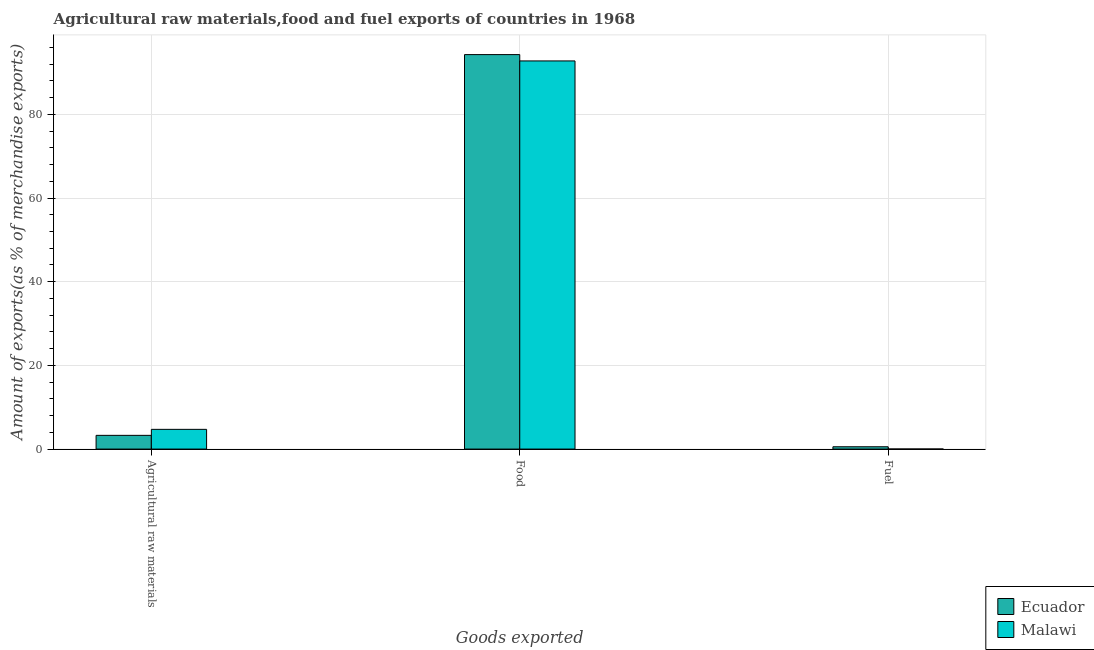How many different coloured bars are there?
Provide a succinct answer. 2. Are the number of bars on each tick of the X-axis equal?
Keep it short and to the point. Yes. How many bars are there on the 1st tick from the left?
Ensure brevity in your answer.  2. How many bars are there on the 2nd tick from the right?
Offer a terse response. 2. What is the label of the 3rd group of bars from the left?
Provide a short and direct response. Fuel. What is the percentage of fuel exports in Ecuador?
Keep it short and to the point. 0.55. Across all countries, what is the maximum percentage of food exports?
Offer a terse response. 94.29. Across all countries, what is the minimum percentage of food exports?
Offer a very short reply. 92.77. In which country was the percentage of food exports maximum?
Your response must be concise. Ecuador. In which country was the percentage of fuel exports minimum?
Provide a short and direct response. Malawi. What is the total percentage of fuel exports in the graph?
Provide a short and direct response. 0.56. What is the difference between the percentage of food exports in Ecuador and that in Malawi?
Give a very brief answer. 1.51. What is the difference between the percentage of fuel exports in Ecuador and the percentage of food exports in Malawi?
Provide a short and direct response. -92.22. What is the average percentage of fuel exports per country?
Offer a terse response. 0.28. What is the difference between the percentage of raw materials exports and percentage of fuel exports in Ecuador?
Give a very brief answer. 2.73. In how many countries, is the percentage of fuel exports greater than 12 %?
Provide a succinct answer. 0. What is the ratio of the percentage of fuel exports in Malawi to that in Ecuador?
Your answer should be compact. 0.02. Is the difference between the percentage of fuel exports in Malawi and Ecuador greater than the difference between the percentage of raw materials exports in Malawi and Ecuador?
Offer a very short reply. No. What is the difference between the highest and the second highest percentage of food exports?
Ensure brevity in your answer.  1.51. What is the difference between the highest and the lowest percentage of raw materials exports?
Your answer should be very brief. 1.43. In how many countries, is the percentage of food exports greater than the average percentage of food exports taken over all countries?
Offer a terse response. 1. Is the sum of the percentage of raw materials exports in Ecuador and Malawi greater than the maximum percentage of fuel exports across all countries?
Offer a very short reply. Yes. What does the 1st bar from the left in Fuel represents?
Your answer should be very brief. Ecuador. What does the 2nd bar from the right in Agricultural raw materials represents?
Give a very brief answer. Ecuador. Is it the case that in every country, the sum of the percentage of raw materials exports and percentage of food exports is greater than the percentage of fuel exports?
Give a very brief answer. Yes. Are all the bars in the graph horizontal?
Keep it short and to the point. No. How many countries are there in the graph?
Your response must be concise. 2. What is the difference between two consecutive major ticks on the Y-axis?
Your response must be concise. 20. Does the graph contain any zero values?
Give a very brief answer. No. Does the graph contain grids?
Make the answer very short. Yes. How many legend labels are there?
Your answer should be very brief. 2. How are the legend labels stacked?
Provide a short and direct response. Vertical. What is the title of the graph?
Your answer should be very brief. Agricultural raw materials,food and fuel exports of countries in 1968. What is the label or title of the X-axis?
Provide a succinct answer. Goods exported. What is the label or title of the Y-axis?
Your answer should be compact. Amount of exports(as % of merchandise exports). What is the Amount of exports(as % of merchandise exports) in Ecuador in Agricultural raw materials?
Make the answer very short. 3.28. What is the Amount of exports(as % of merchandise exports) of Malawi in Agricultural raw materials?
Make the answer very short. 4.71. What is the Amount of exports(as % of merchandise exports) of Ecuador in Food?
Provide a succinct answer. 94.29. What is the Amount of exports(as % of merchandise exports) of Malawi in Food?
Your response must be concise. 92.77. What is the Amount of exports(as % of merchandise exports) of Ecuador in Fuel?
Provide a short and direct response. 0.55. What is the Amount of exports(as % of merchandise exports) of Malawi in Fuel?
Give a very brief answer. 0.01. Across all Goods exported, what is the maximum Amount of exports(as % of merchandise exports) of Ecuador?
Ensure brevity in your answer.  94.29. Across all Goods exported, what is the maximum Amount of exports(as % of merchandise exports) of Malawi?
Your response must be concise. 92.77. Across all Goods exported, what is the minimum Amount of exports(as % of merchandise exports) in Ecuador?
Your response must be concise. 0.55. Across all Goods exported, what is the minimum Amount of exports(as % of merchandise exports) in Malawi?
Your response must be concise. 0.01. What is the total Amount of exports(as % of merchandise exports) of Ecuador in the graph?
Keep it short and to the point. 98.12. What is the total Amount of exports(as % of merchandise exports) in Malawi in the graph?
Give a very brief answer. 97.5. What is the difference between the Amount of exports(as % of merchandise exports) in Ecuador in Agricultural raw materials and that in Food?
Offer a very short reply. -91. What is the difference between the Amount of exports(as % of merchandise exports) of Malawi in Agricultural raw materials and that in Food?
Keep it short and to the point. -88.06. What is the difference between the Amount of exports(as % of merchandise exports) in Ecuador in Agricultural raw materials and that in Fuel?
Offer a terse response. 2.73. What is the difference between the Amount of exports(as % of merchandise exports) of Malawi in Agricultural raw materials and that in Fuel?
Your response must be concise. 4.7. What is the difference between the Amount of exports(as % of merchandise exports) in Ecuador in Food and that in Fuel?
Your response must be concise. 93.73. What is the difference between the Amount of exports(as % of merchandise exports) of Malawi in Food and that in Fuel?
Your response must be concise. 92.76. What is the difference between the Amount of exports(as % of merchandise exports) in Ecuador in Agricultural raw materials and the Amount of exports(as % of merchandise exports) in Malawi in Food?
Offer a very short reply. -89.49. What is the difference between the Amount of exports(as % of merchandise exports) of Ecuador in Agricultural raw materials and the Amount of exports(as % of merchandise exports) of Malawi in Fuel?
Your answer should be very brief. 3.27. What is the difference between the Amount of exports(as % of merchandise exports) of Ecuador in Food and the Amount of exports(as % of merchandise exports) of Malawi in Fuel?
Your answer should be very brief. 94.27. What is the average Amount of exports(as % of merchandise exports) in Ecuador per Goods exported?
Ensure brevity in your answer.  32.71. What is the average Amount of exports(as % of merchandise exports) of Malawi per Goods exported?
Offer a terse response. 32.5. What is the difference between the Amount of exports(as % of merchandise exports) in Ecuador and Amount of exports(as % of merchandise exports) in Malawi in Agricultural raw materials?
Offer a terse response. -1.43. What is the difference between the Amount of exports(as % of merchandise exports) in Ecuador and Amount of exports(as % of merchandise exports) in Malawi in Food?
Provide a short and direct response. 1.51. What is the difference between the Amount of exports(as % of merchandise exports) of Ecuador and Amount of exports(as % of merchandise exports) of Malawi in Fuel?
Your answer should be compact. 0.54. What is the ratio of the Amount of exports(as % of merchandise exports) in Ecuador in Agricultural raw materials to that in Food?
Ensure brevity in your answer.  0.03. What is the ratio of the Amount of exports(as % of merchandise exports) in Malawi in Agricultural raw materials to that in Food?
Ensure brevity in your answer.  0.05. What is the ratio of the Amount of exports(as % of merchandise exports) of Ecuador in Agricultural raw materials to that in Fuel?
Ensure brevity in your answer.  5.94. What is the ratio of the Amount of exports(as % of merchandise exports) of Malawi in Agricultural raw materials to that in Fuel?
Provide a succinct answer. 384.64. What is the ratio of the Amount of exports(as % of merchandise exports) of Ecuador in Food to that in Fuel?
Make the answer very short. 170.61. What is the ratio of the Amount of exports(as % of merchandise exports) in Malawi in Food to that in Fuel?
Your answer should be compact. 7571.83. What is the difference between the highest and the second highest Amount of exports(as % of merchandise exports) in Ecuador?
Your answer should be compact. 91. What is the difference between the highest and the second highest Amount of exports(as % of merchandise exports) of Malawi?
Offer a very short reply. 88.06. What is the difference between the highest and the lowest Amount of exports(as % of merchandise exports) of Ecuador?
Offer a very short reply. 93.73. What is the difference between the highest and the lowest Amount of exports(as % of merchandise exports) of Malawi?
Provide a short and direct response. 92.76. 